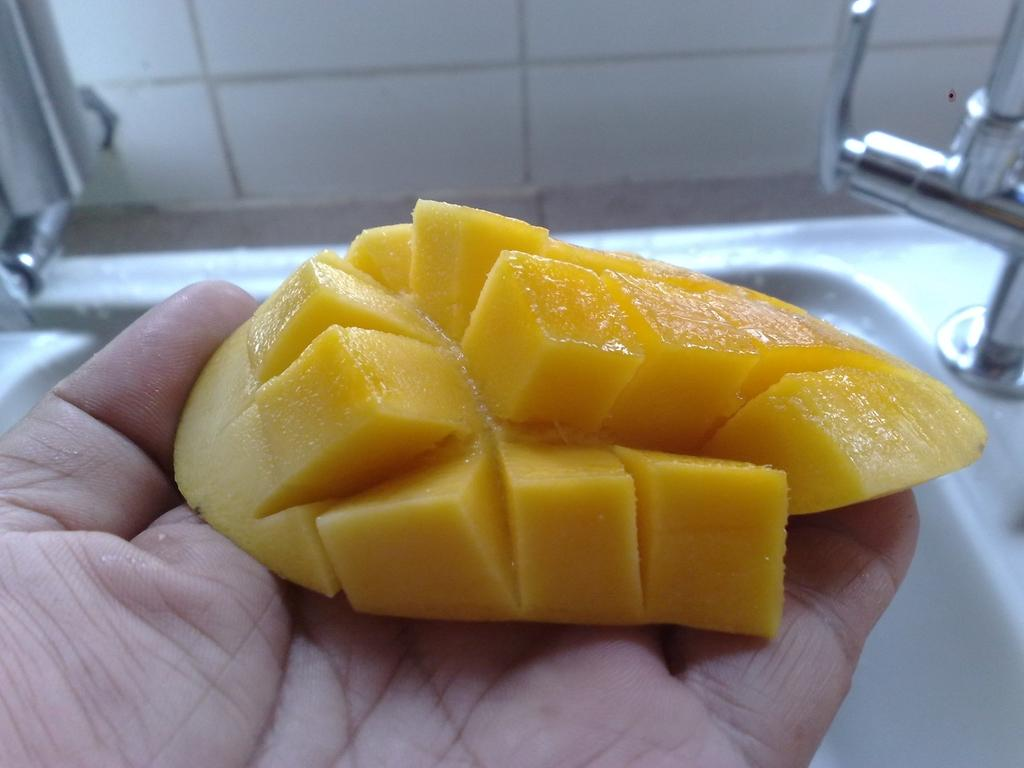What fruit is visible in the image? There is a piece of mango in the image. Who is holding the mango in the image? The mango is in the human hand. What is the color of the mango? The mango is yellow in color. What can be seen in the background of the image? There is a white color sink, a tap, and a wall in the background of the image. How many rings does the grandmother wear on her fingers in the image? There is no grandmother or rings present in the image. 